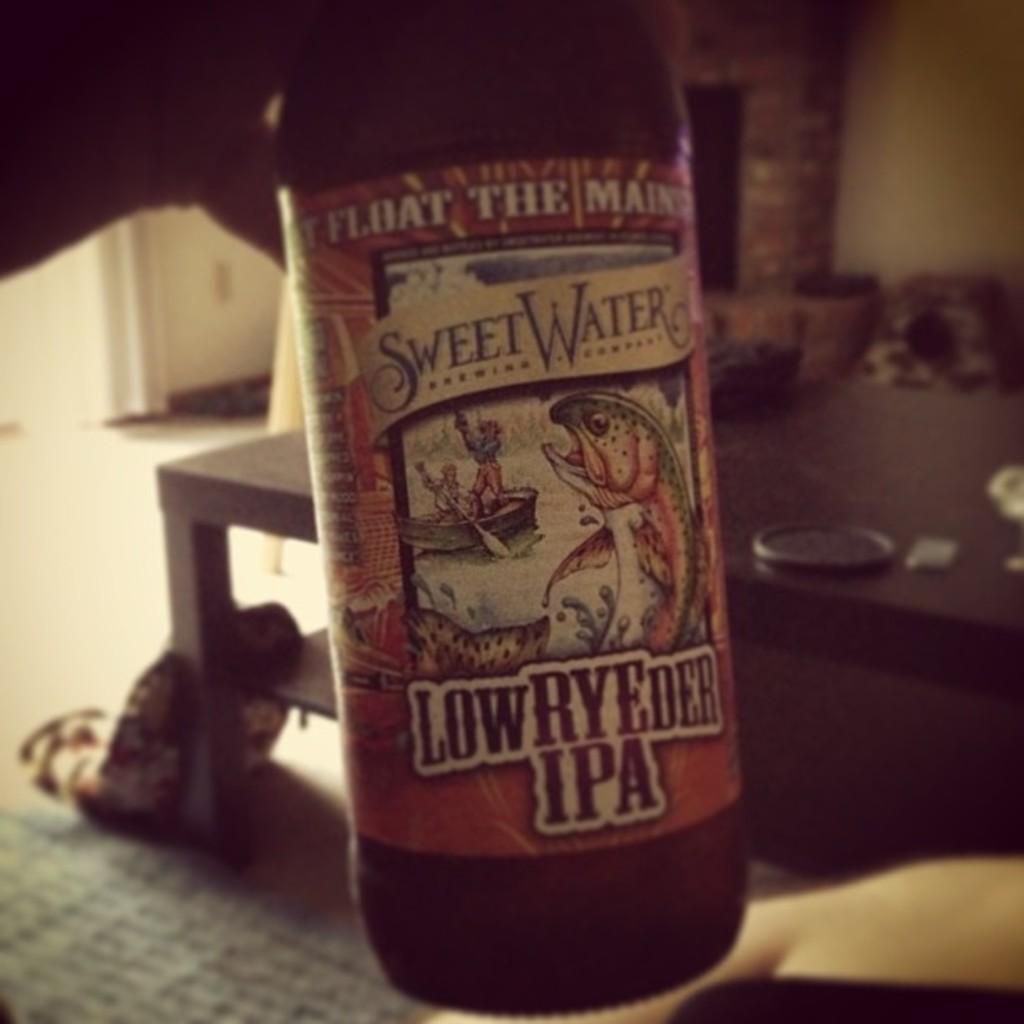<image>
Write a terse but informative summary of the picture. A bottle of SweetWater LowRYEder IPA is being held in front of a brick fireplace 